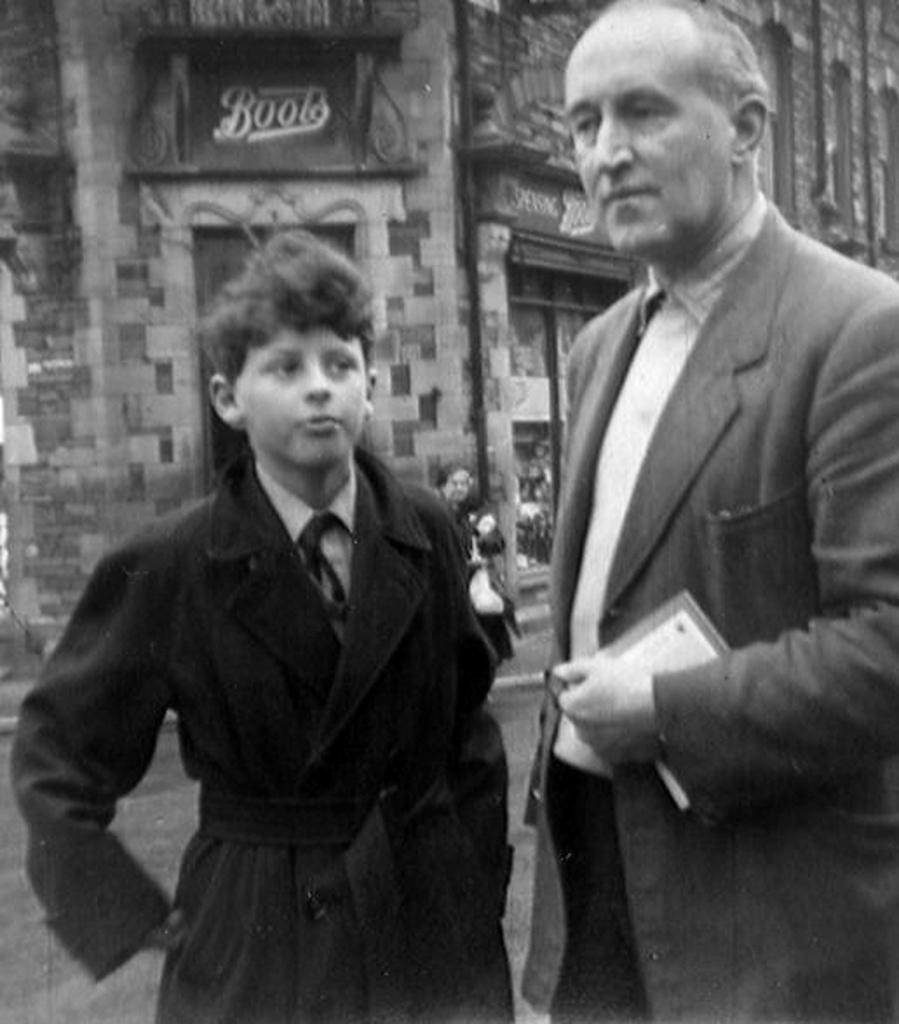How many people are present in the image? There are two people standing in the image. What can be seen in the background of the image? There is a building and a person visible in the background of the image. What object is present in the image that might be used for displaying information? There is a board in the image. What is the man standing on the right holding? The man standing on the right is holding a book. What type of lace can be seen on the shoes of the person in the background? There is no information about the person's shoes or any lace in the image. --- 